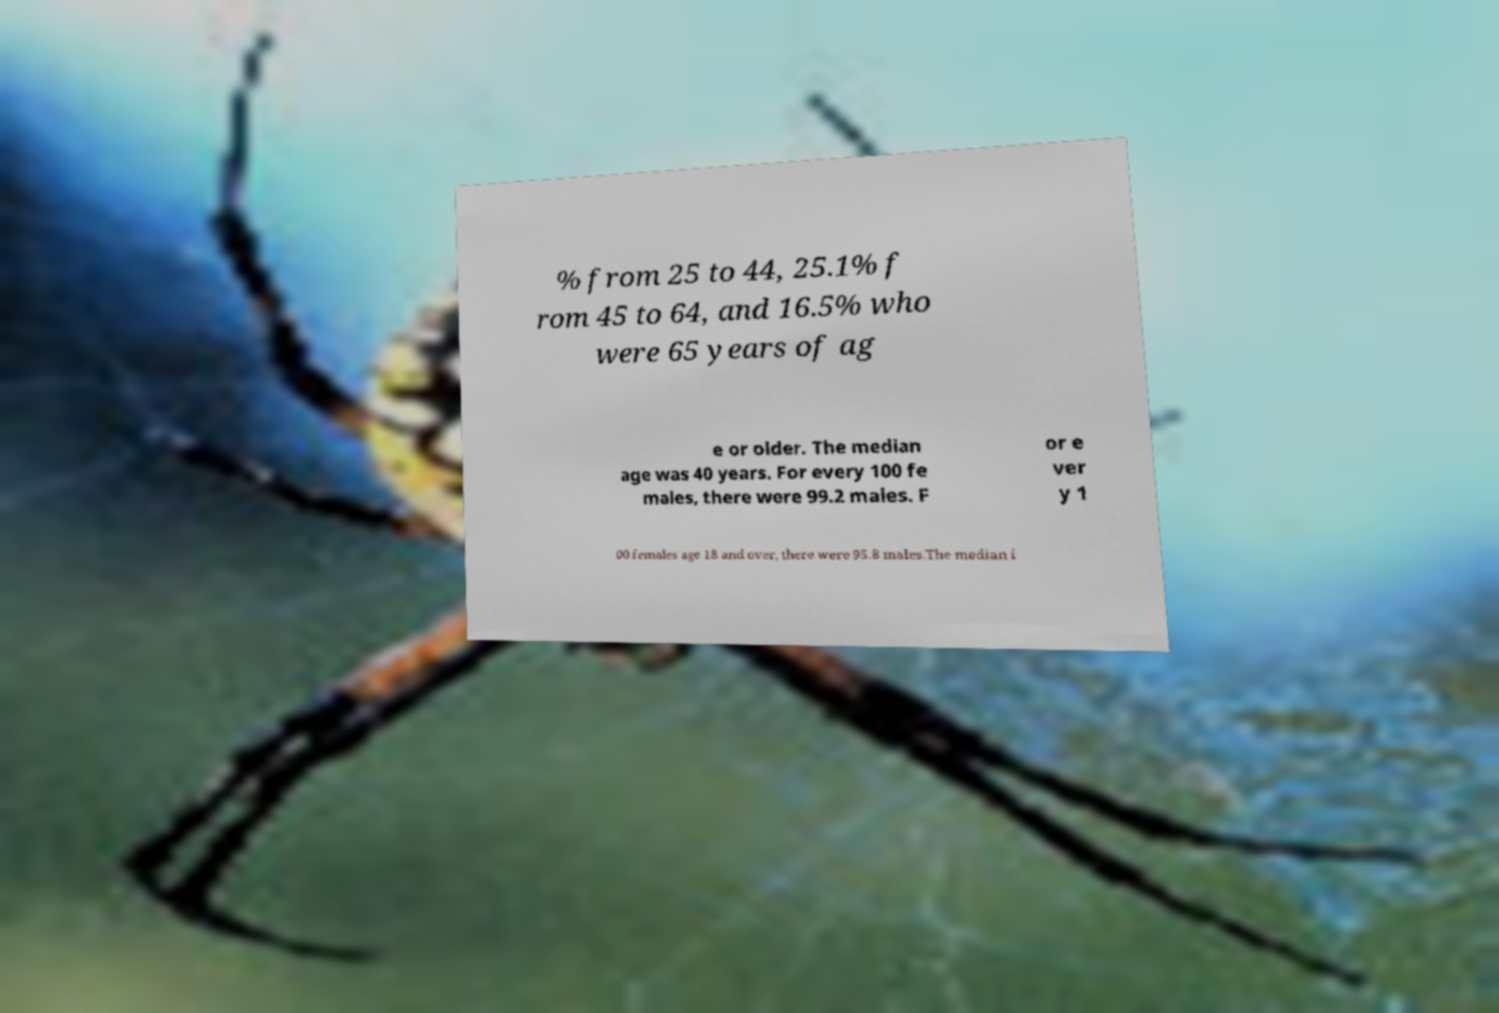Please identify and transcribe the text found in this image. % from 25 to 44, 25.1% f rom 45 to 64, and 16.5% who were 65 years of ag e or older. The median age was 40 years. For every 100 fe males, there were 99.2 males. F or e ver y 1 00 females age 18 and over, there were 95.8 males.The median i 